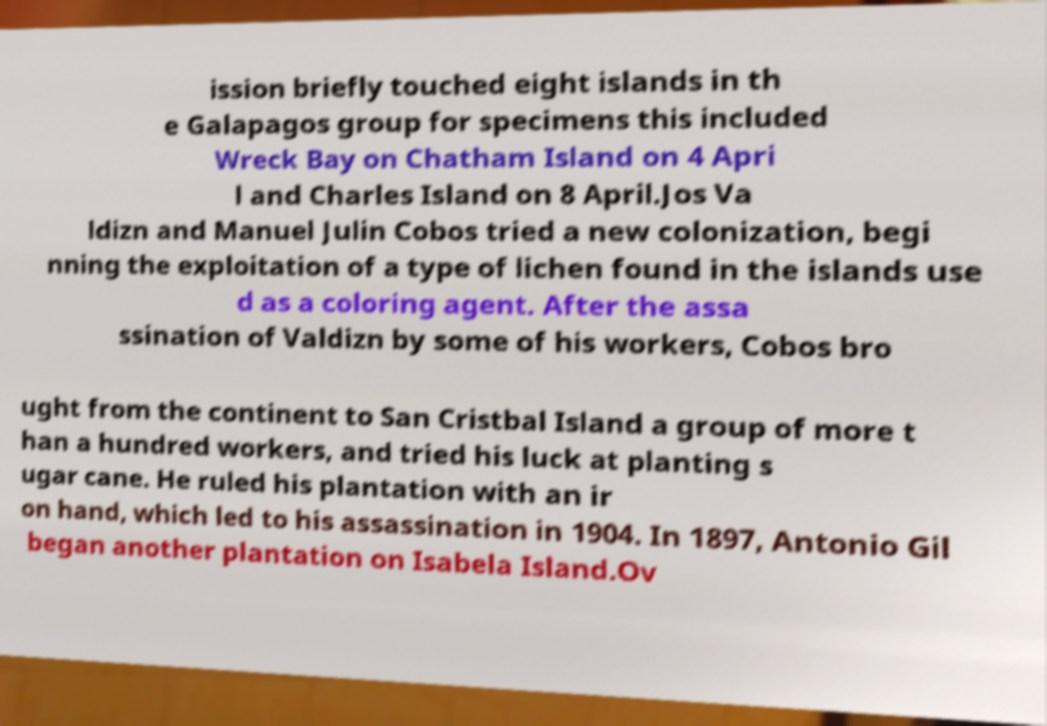Could you extract and type out the text from this image? ission briefly touched eight islands in th e Galapagos group for specimens this included Wreck Bay on Chatham Island on 4 Apri l and Charles Island on 8 April.Jos Va ldizn and Manuel Julin Cobos tried a new colonization, begi nning the exploitation of a type of lichen found in the islands use d as a coloring agent. After the assa ssination of Valdizn by some of his workers, Cobos bro ught from the continent to San Cristbal Island a group of more t han a hundred workers, and tried his luck at planting s ugar cane. He ruled his plantation with an ir on hand, which led to his assassination in 1904. In 1897, Antonio Gil began another plantation on Isabela Island.Ov 